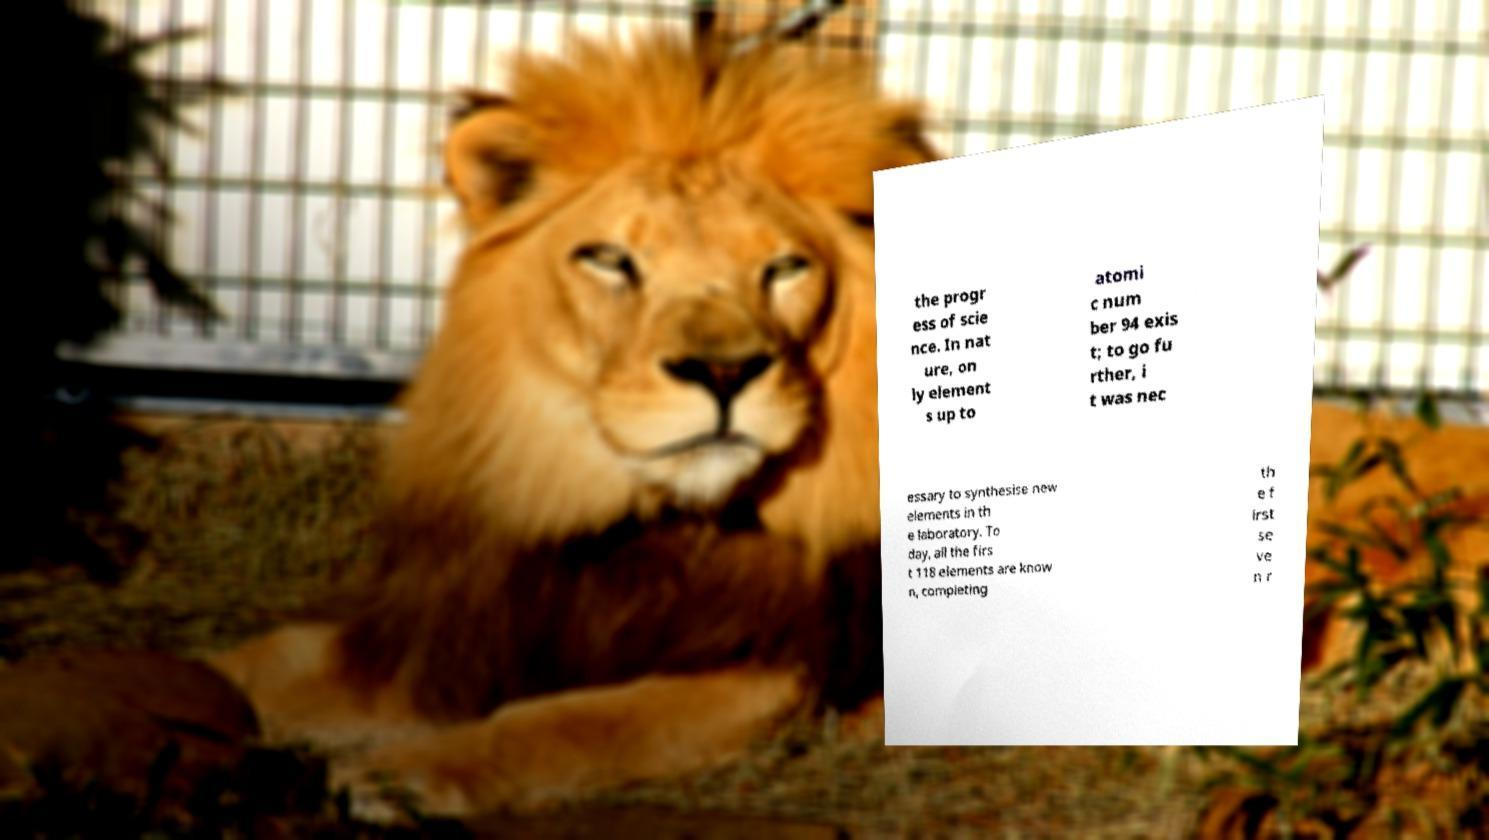For documentation purposes, I need the text within this image transcribed. Could you provide that? the progr ess of scie nce. In nat ure, on ly element s up to atomi c num ber 94 exis t; to go fu rther, i t was nec essary to synthesise new elements in th e laboratory. To day, all the firs t 118 elements are know n, completing th e f irst se ve n r 